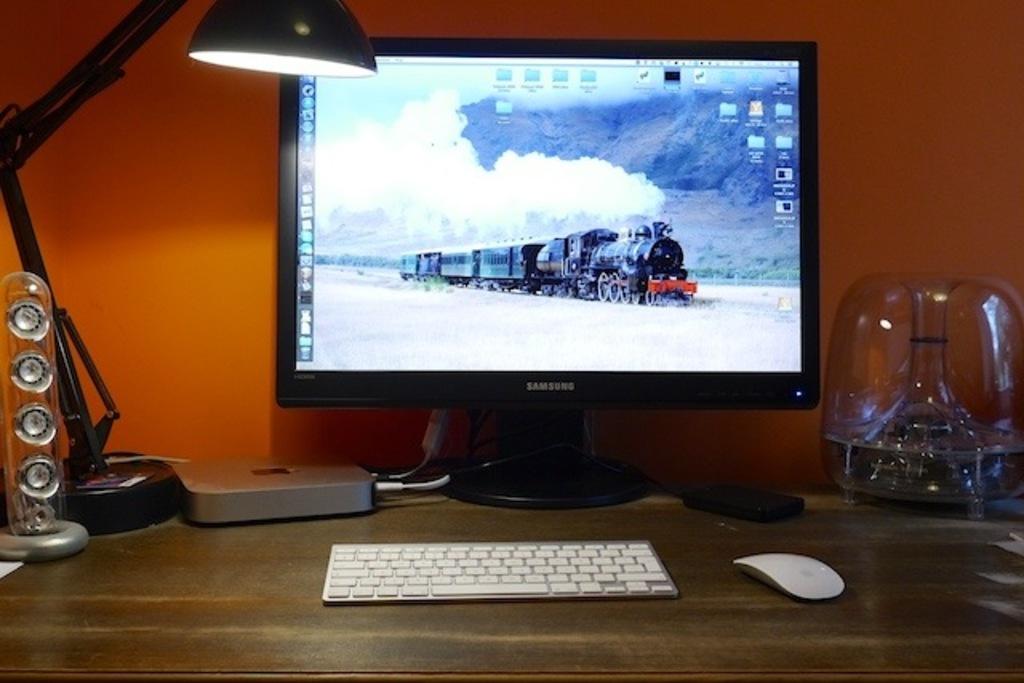What brand of computer monitor?
Your answer should be very brief. Samsung. 